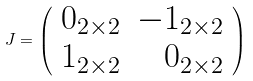<formula> <loc_0><loc_0><loc_500><loc_500>J = \left ( \begin{array} { c r } 0 _ { 2 \times 2 } & - 1 _ { 2 \times 2 } \\ 1 _ { 2 \times 2 } & 0 _ { 2 \times 2 } \end{array} \right )</formula> 